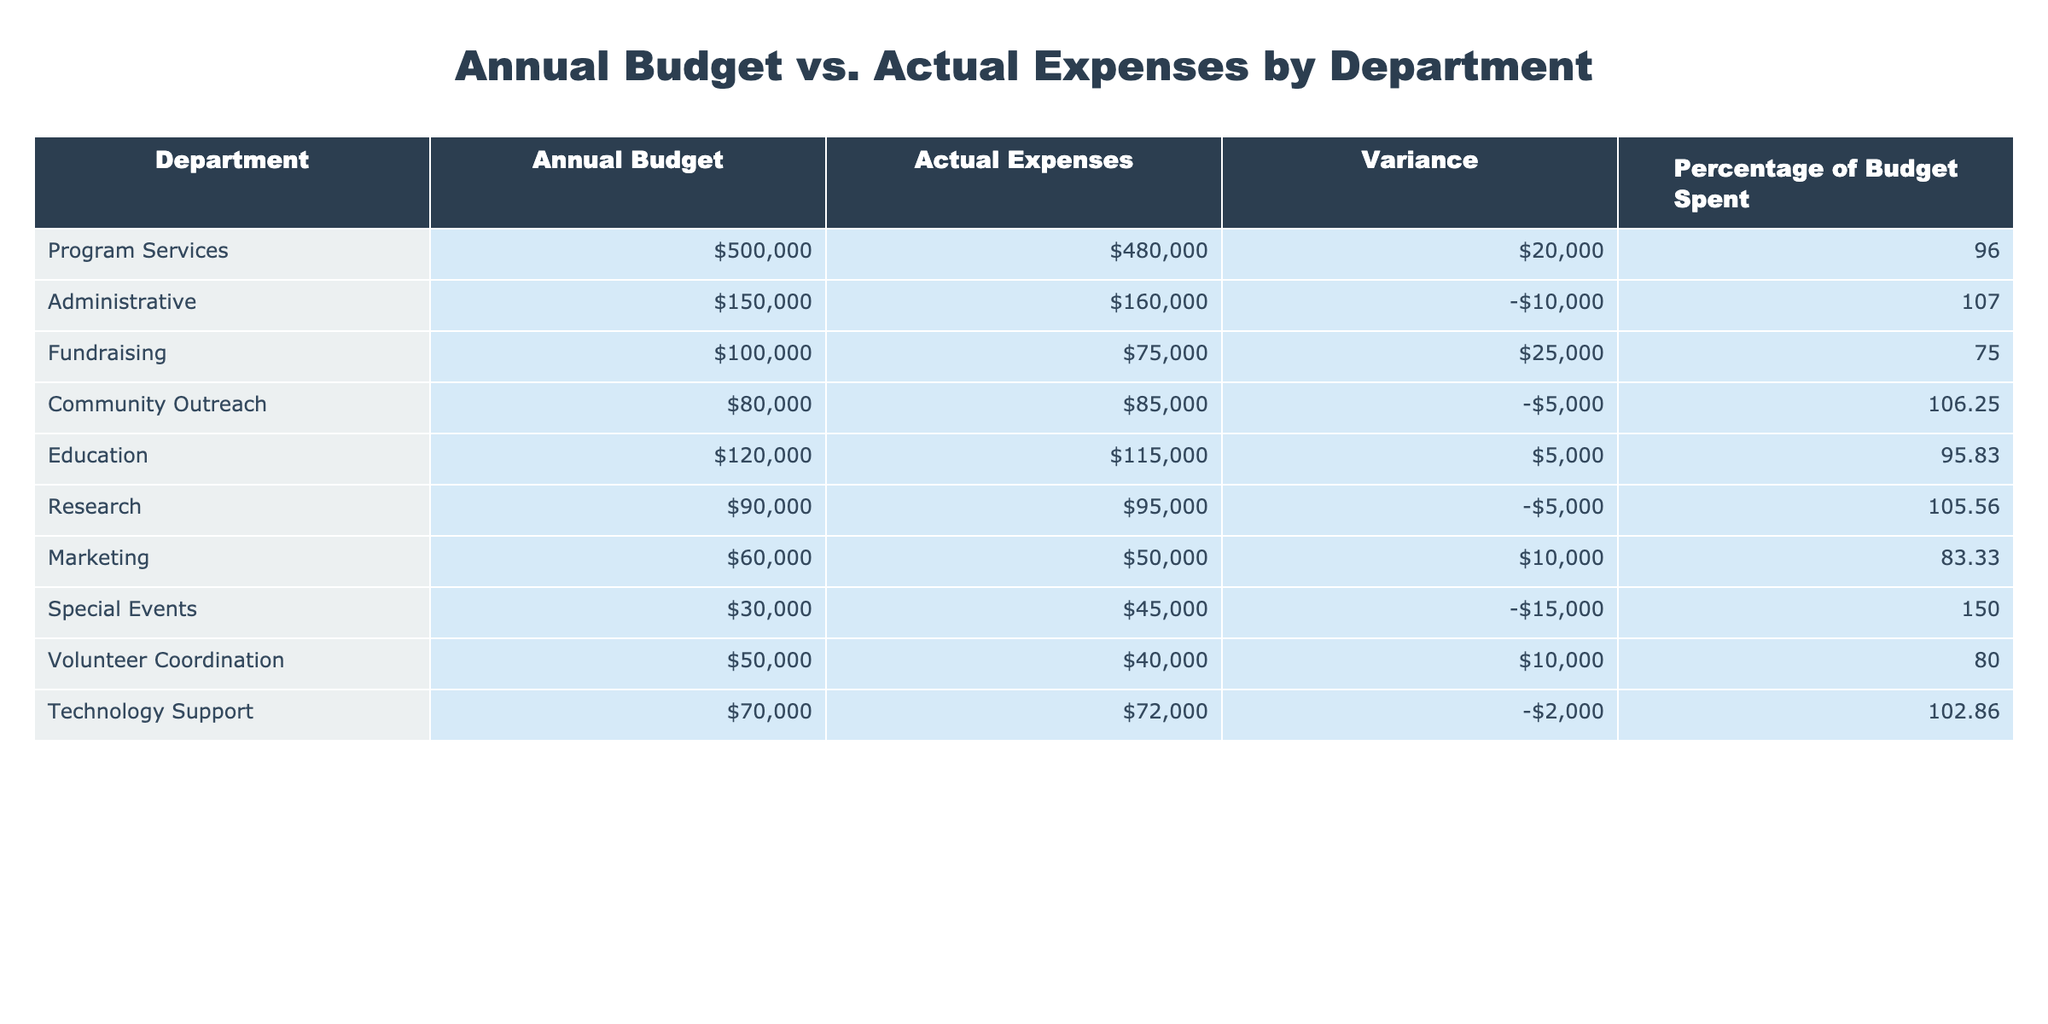What is the annual budget for the Fundraising department? By looking at the table, I can see that the Fundraising department has an annual budget listed directly under the "Annual Budget" column. The value for Fundraising is 100,000.
Answer: 100000 What are the actual expenses for the Program Services department? The actual expenses for the Program Services department can be found in the "Actual Expenses" column next to Program Services, which shows a value of 480,000.
Answer: 480000 What is the variance for the Administrative department? To find the variance for the Administrative department, I can refer to the "Variance" column in the table where the Administrative department is located, showing a value of -10,000.
Answer: -10000 Which department had the highest percentage of budget spent? I can compare the "Percentage of Budget Spent" column for each department, and the Special Events department has the highest value at 150%.
Answer: Special Events What is the total actual expense across all departments? To calculate the total actual expenses, I will sum the numbers in the "Actual Expenses" column: 480000 + 160000 + 75000 + 85000 + 115000 + 95000 + 50000 + 45000 + 40000 + 72000 = 1,463,000.
Answer: 1463000 Did the Technology Support department stay within its budget? I will check the "Variance" column for the Technology Support department. Its variance is -2,000, indicating that it exceeded its budget.
Answer: No Which departments had a negative variance? To determine which departments had a negative variance, I will look at the "Variance" column and note that the Administrative, Community Outreach, Research, Special Events, and Technology Support departments have negative variances.
Answer: Administrative, Community Outreach, Research, Special Events, Technology Support What is the average percentage of budget spent for all departments? To find the average percentage spent, I will sum the values in the "Percentage of Budget Spent" column (96 + 107 + 75 + 106.25 + 95.83 + 105.56 + 83.33 + 150 + 80 + 102.86 = 1,018.83) and divide by the number of departments (10). The average is approximately 101.88%.
Answer: 101.88 Which department spent the least relative to its budget? I will look for the lowest number in the "Percentage of Budget Spent" column. Fundraising has the lowest percentage spent at 75%.
Answer: Fundraising What is the total budget for all departments? I will calculate the total budget by summing the values in the "Annual Budget" column: 500000 + 150000 + 100000 + 80000 + 120000 + 90000 + 60000 + 30000 + 50000 + 70000 = 1,570,000.
Answer: 1570000 